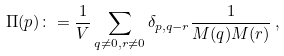<formula> <loc_0><loc_0><loc_500><loc_500>\Pi ( p ) \colon = \frac { 1 } { V } \sum _ { q \neq 0 , r \neq 0 } \delta _ { p , q - r } \frac { 1 } { M ( q ) M ( r ) } \, ,</formula> 